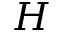<formula> <loc_0><loc_0><loc_500><loc_500>H</formula> 